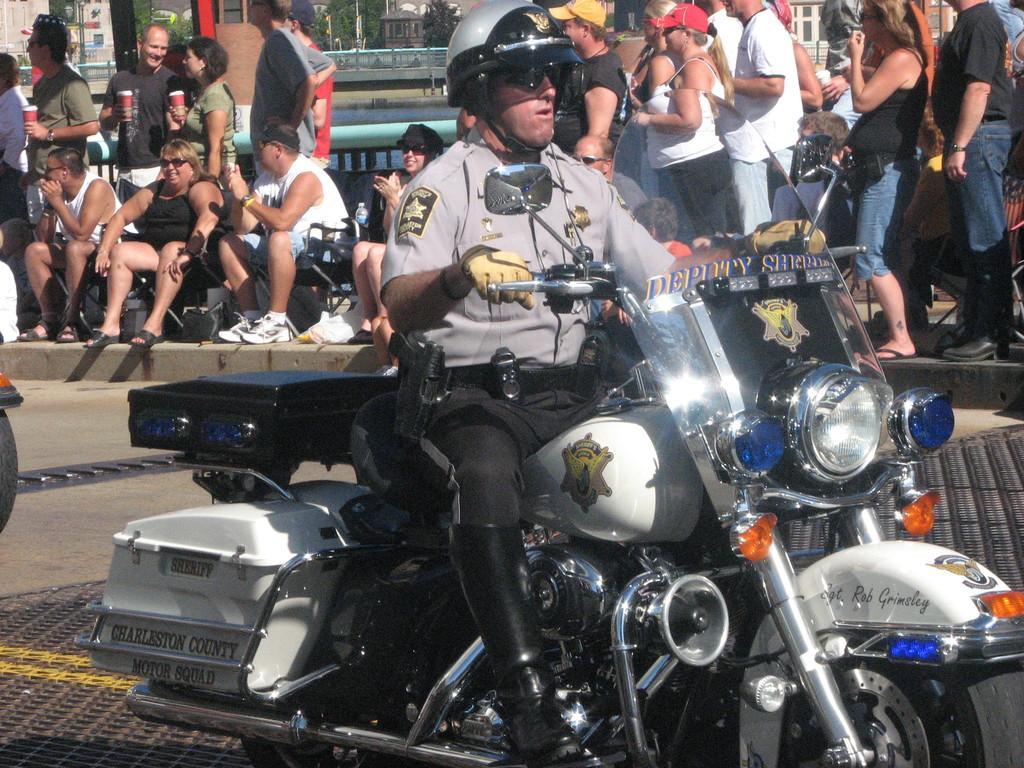Describe this image in one or two sentences. As we can see in the image there are few people sitting on chairs and few of them are standing and in the front there is a man sitting on motor cycle. 